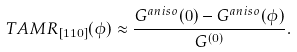Convert formula to latex. <formula><loc_0><loc_0><loc_500><loc_500>T A M R _ { [ 1 1 0 ] } ( \phi ) \approx \frac { G ^ { a n i s o } ( 0 ) - G ^ { a n i s o } ( \phi ) } { G ^ { ( 0 ) } } .</formula> 